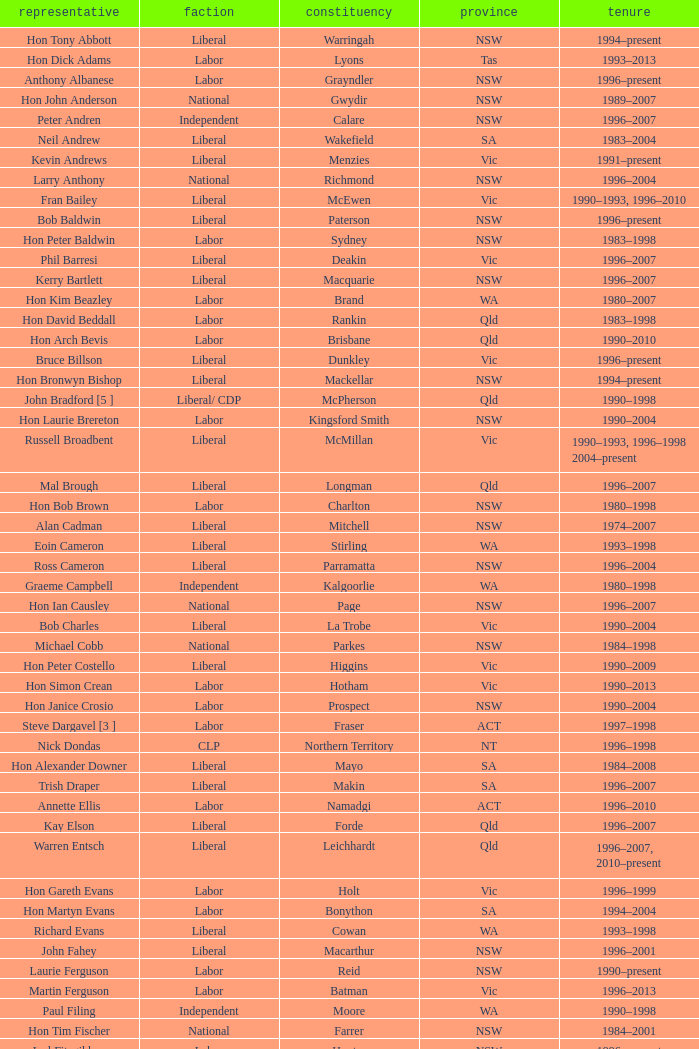Can you give me this table as a dict? {'header': ['representative', 'faction', 'constituency', 'province', 'tenure'], 'rows': [['Hon Tony Abbott', 'Liberal', 'Warringah', 'NSW', '1994–present'], ['Hon Dick Adams', 'Labor', 'Lyons', 'Tas', '1993–2013'], ['Anthony Albanese', 'Labor', 'Grayndler', 'NSW', '1996–present'], ['Hon John Anderson', 'National', 'Gwydir', 'NSW', '1989–2007'], ['Peter Andren', 'Independent', 'Calare', 'NSW', '1996–2007'], ['Neil Andrew', 'Liberal', 'Wakefield', 'SA', '1983–2004'], ['Kevin Andrews', 'Liberal', 'Menzies', 'Vic', '1991–present'], ['Larry Anthony', 'National', 'Richmond', 'NSW', '1996–2004'], ['Fran Bailey', 'Liberal', 'McEwen', 'Vic', '1990–1993, 1996–2010'], ['Bob Baldwin', 'Liberal', 'Paterson', 'NSW', '1996–present'], ['Hon Peter Baldwin', 'Labor', 'Sydney', 'NSW', '1983–1998'], ['Phil Barresi', 'Liberal', 'Deakin', 'Vic', '1996–2007'], ['Kerry Bartlett', 'Liberal', 'Macquarie', 'NSW', '1996–2007'], ['Hon Kim Beazley', 'Labor', 'Brand', 'WA', '1980–2007'], ['Hon David Beddall', 'Labor', 'Rankin', 'Qld', '1983–1998'], ['Hon Arch Bevis', 'Labor', 'Brisbane', 'Qld', '1990–2010'], ['Bruce Billson', 'Liberal', 'Dunkley', 'Vic', '1996–present'], ['Hon Bronwyn Bishop', 'Liberal', 'Mackellar', 'NSW', '1994–present'], ['John Bradford [5 ]', 'Liberal/ CDP', 'McPherson', 'Qld', '1990–1998'], ['Hon Laurie Brereton', 'Labor', 'Kingsford Smith', 'NSW', '1990–2004'], ['Russell Broadbent', 'Liberal', 'McMillan', 'Vic', '1990–1993, 1996–1998 2004–present'], ['Mal Brough', 'Liberal', 'Longman', 'Qld', '1996–2007'], ['Hon Bob Brown', 'Labor', 'Charlton', 'NSW', '1980–1998'], ['Alan Cadman', 'Liberal', 'Mitchell', 'NSW', '1974–2007'], ['Eoin Cameron', 'Liberal', 'Stirling', 'WA', '1993–1998'], ['Ross Cameron', 'Liberal', 'Parramatta', 'NSW', '1996–2004'], ['Graeme Campbell', 'Independent', 'Kalgoorlie', 'WA', '1980–1998'], ['Hon Ian Causley', 'National', 'Page', 'NSW', '1996–2007'], ['Bob Charles', 'Liberal', 'La Trobe', 'Vic', '1990–2004'], ['Michael Cobb', 'National', 'Parkes', 'NSW', '1984–1998'], ['Hon Peter Costello', 'Liberal', 'Higgins', 'Vic', '1990–2009'], ['Hon Simon Crean', 'Labor', 'Hotham', 'Vic', '1990–2013'], ['Hon Janice Crosio', 'Labor', 'Prospect', 'NSW', '1990–2004'], ['Steve Dargavel [3 ]', 'Labor', 'Fraser', 'ACT', '1997–1998'], ['Nick Dondas', 'CLP', 'Northern Territory', 'NT', '1996–1998'], ['Hon Alexander Downer', 'Liberal', 'Mayo', 'SA', '1984–2008'], ['Trish Draper', 'Liberal', 'Makin', 'SA', '1996–2007'], ['Annette Ellis', 'Labor', 'Namadgi', 'ACT', '1996–2010'], ['Kay Elson', 'Liberal', 'Forde', 'Qld', '1996–2007'], ['Warren Entsch', 'Liberal', 'Leichhardt', 'Qld', '1996–2007, 2010–present'], ['Hon Gareth Evans', 'Labor', 'Holt', 'Vic', '1996–1999'], ['Hon Martyn Evans', 'Labor', 'Bonython', 'SA', '1994–2004'], ['Richard Evans', 'Liberal', 'Cowan', 'WA', '1993–1998'], ['John Fahey', 'Liberal', 'Macarthur', 'NSW', '1996–2001'], ['Laurie Ferguson', 'Labor', 'Reid', 'NSW', '1990–present'], ['Martin Ferguson', 'Labor', 'Batman', 'Vic', '1996–2013'], ['Paul Filing', 'Independent', 'Moore', 'WA', '1990–1998'], ['Hon Tim Fischer', 'National', 'Farrer', 'NSW', '1984–2001'], ['Joel Fitzgibbon', 'Labor', 'Hunter', 'NSW', '1996–present'], ['John Forrest', 'National', 'Mallee', 'Vic', '1993–2013'], ['Christine Gallus', 'Liberal', 'Hindmarsh', 'SA', '1990–2004'], ['Teresa Gambaro', 'Liberal', 'Petrie', 'Qld', '1996–2007, 2010–present'], ['Joanna Gash', 'Liberal', 'Gilmore', 'NSW', '1996–2013'], ['Petro Georgiou', 'Liberal', 'Kooyong', 'Vic', '1994–2010'], ['Ted Grace', 'Labor', 'Fowler', 'NSW', '1984–1998'], ['Elizabeth Grace', 'Liberal', 'Lilley', 'Qld', '1996–1998'], ['Alan Griffin', 'Labor', 'Bruce', 'Vic', '1993–present'], ['Bob Halverson', 'Liberal', 'Casey', 'Vic', '1984–1998'], ['Pauline Hanson [4 ]', 'Independent/ ONP', 'Oxley', 'Qld', '1996–1998'], ['Gary Hardgrave', 'Liberal', 'Moreton', 'Qld', '1996–2007'], ['Michael Hatton [1 ]', 'Labor', 'Blaxland', 'NSW', '1996–2007'], ['David Hawker', 'Liberal', 'Wannon', 'Vic', '1983–2010'], ['Noel Hicks', 'National', 'Riverina', 'NSW', '1980–1998'], ['Joe Hockey', 'Liberal', 'North Sydney', 'NSW', '1996–present'], ['Hon Clyde Holding', 'Labor', 'Melbourne Ports', 'Vic', '1977–1998'], ['Colin Hollis', 'Labor', 'Throsby', 'NSW', '1984–2001'], ['Hon John Howard', 'Liberal', 'Bennelong', 'NSW', '1974–2007'], ['Susan Jeanes', 'Liberal', 'Kingston', 'SA', '1996–1998'], ['Harry Jenkins', 'Labor', 'Scullin', 'Vic', '1986–2013'], ['Ricky Johnston', 'Liberal', 'Canning', 'WA', '1996–1998'], ['Hon Barry Jones', 'Labor', 'Lalor', 'Vic', '1977–1998'], ['Hon David Jull', 'Liberal', 'Fadden', 'Qld', '1975–1983, 1984–2007'], ['Hon Bob Katter', 'National', 'Kennedy', 'Qld', '1993–present'], ['Paul Keating [1 ]', 'Labor', 'Blaxland', 'NSW', '1969–1996'], ['De-Anne Kelly', 'National', 'Dawson', 'Qld', '1996–2007'], ['Jackie Kelly [2 ]', 'Liberal', 'Lindsay', 'NSW', '1996–2007'], ['Hon Dr David Kemp', 'Liberal', 'Goldstein', 'Vic', '1990–2004'], ['Hon Duncan Kerr', 'Labor', 'Denison', 'Tas', '1987–2010'], ['John Langmore [3 ]', 'Labor', 'Fraser', 'ACT', '1984–1997'], ['Mark Latham', 'Labor', 'Werriwa', 'NSW', '1994–2005'], ['Hon Dr Carmen Lawrence', 'Labor', 'Fremantle', 'WA', '1994–2007'], ['Hon Michael Lee', 'Labor', 'Dobell', 'NSW', '1984–2001'], ['Hon Lou Lieberman', 'Liberal', 'Indi', 'Vic', '1993–2001'], ['Peter Lindsay', 'Liberal', 'Herbert', 'Qld', '1996–2010'], ['Jim Lloyd', 'Liberal', 'Robertson', 'NSW', '1996–2007'], ['Stewart McArthur', 'Liberal', 'Corangamite', 'Vic', '1984–2007'], ['Robert McClelland', 'Labor', 'Barton', 'NSW', '1996–2013'], ['Graeme McDougall', 'Liberal', 'Griffith', 'Qld', '1996–1998'], ['Hon Peter McGauran', 'National', 'Gippsland', 'Vic', '1983–2008'], ['Hon Ian McLachlan', 'Liberal', 'Barker', 'SA', '1990–1998'], ['Hon Leo McLeay', 'Labor', 'Watson', 'NSW', '1979–2004'], ['Hon Bob McMullan', 'Labor', 'Canberra', 'ACT', '1996–2010'], ['Jenny Macklin', 'Labor', 'Jagajaga', 'Vic', '1996–present'], ['Paul Marek', 'National', 'Capricornia', 'Qld', '1996–1998'], ['Hon Stephen Martin', 'Labor', 'Cunningham', 'NSW', '1984–2002'], ['Daryl Melham', 'Labor', 'Banks', 'NSW', '1990–2013'], ['Hon Chris Miles', 'Liberal', 'Braddon', 'Tas', '1984–1998'], ['Hon John Moore', 'Liberal', 'Ryan', 'Qld', '1975–2001'], ['Allan Morris', 'Labor', 'Newcastle', 'NSW', '1983–2001'], ['Hon Peter Morris', 'Labor', 'Shortland', 'NSW', '1972–1998'], ['Frank Mossfield', 'Labor', 'Greenway', 'NSW', '1996–2004'], ['Hon Judi Moylan', 'Liberal', 'Pearce', 'WA', '1993–2013'], ['Stephen Mutch', 'Liberal', 'Cook', 'NSW', '1996–1998'], ['Gary Nairn', 'Liberal', 'Eden-Monaro', 'NSW', '1996–2007'], ['Garry Nehl', 'National', 'Cowper', 'NSW', '1984–2001'], ['Dr Brendan Nelson', 'Liberal', 'Bradfield', 'NSW', '1996–2009'], ['Paul Neville', 'National', 'Hinkler', 'Qld', '1993–2013'], ['Peter Nugent', 'Liberal', 'Aston', 'Vic', '1990–2001'], ["Gavan O'Connor", 'Labor', 'Corio', 'Vic', '1993–2007'], ["Hon Neil O'Keefe", 'Labor', 'Burke', 'Vic', '1984–2001'], ['Hon Roger Price', 'Labor', 'Chifley', 'NSW', '1984–2010'], ['Hon Geoff Prosser', 'Liberal', 'Forrest', 'WA', '1987–2007'], ['Christopher Pyne', 'Liberal', 'Sturt', 'SA', '1993–present'], ['Harry Quick', 'Labor', 'Franklin', 'Tas', '1993–2007'], ['Don Randall', 'Liberal', 'Swan', 'WA', '1996–1998, 2001–present'], ['Hon Bruce Reid', 'Liberal', 'Bendigo', 'Vic', '1990–1998'], ['Hon Peter Reith', 'Liberal', 'Flinders', 'Vic', '1982–1983, 1984–2001'], ['Allan Rocher', 'Independent', 'Curtin', 'WA', '1981–1998'], ['Michael Ronaldson', 'Liberal', 'Ballarat', 'Vic', '1990–2001'], ['Hon Philip Ruddock', 'Liberal', 'Berowra', 'NSW', '1973–present'], ['Rod Sawford', 'Labor', 'Adelaide', 'SA', '1988–2007'], ['Hon Bruce Scott', 'National', 'Maranoa', 'Qld', '1990–present'], ['Bob Sercombe', 'Labor', 'Maribyrnong', 'Vic', '1996–2007'], ['Hon John Sharp', 'National', 'Hume', 'NSW', '1984–1998'], ['Hon Ian Sinclair', 'National', 'New England', 'NSW', '1963–1998'], ['Peter Slipper', 'Liberal', 'Fisher', 'Qld', '1984–1987, 1993–2013'], ['Tony Smith', 'Liberal/Independent [7 ]', 'Dickson', 'Qld', '1996–1998'], ['Stephen Smith', 'Labor', 'Perth', 'WA', '1993–2013'], ['Hon Warwick Smith', 'Liberal', 'Bass', 'Tas', '1984–1993, 1996–1998'], ['Alex Somlyay', 'Liberal', 'Fairfax', 'Qld', '1990–2013'], ['Dr Andrew Southcott', 'Liberal', 'Boothby', 'SA', '1996–present'], ['Dr Sharman Stone', 'Liberal', 'Murray', 'Vic', '1996–present'], ['Kathy Sullivan', 'Liberal', 'Moncrieff', 'Qld', '1984–2001'], ['Lindsay Tanner', 'Labor', 'Melbourne', 'Vic', '1993–2010'], ['Bill Taylor', 'Liberal', 'Groom', 'Qld', '1988–1998'], ['Hon Andrew Theophanous', 'Labor', 'Calwell', 'Vic', '1980–2001'], ['Hon Andrew Thomson', 'Liberal', 'Wentworth', 'NSW', '1995–2001'], ['Kelvin Thomson', 'Labor', 'Wills', 'Vic', '1996–present'], ['Warren Truss', 'National', 'Wide Bay', 'Qld', '1990–present'], ['Wilson Tuckey', 'Liberal', "O'Connor", 'WA', '1980–2010'], ['Mark Vaile', 'National', 'Lyne', 'NSW', '1993–2008'], ['Danna Vale', 'Liberal', 'Hughes', 'NSW', '1996–2010'], ['Barry Wakelin', 'Liberal', 'Grey', 'SA', '1993–2007'], ['Andrea West', 'Liberal', 'Bowman', 'Qld', '1996–1998'], ['Hon Daryl Williams', 'Liberal', 'Tangney', 'WA', '1993–2004'], ['Hon Ralph Willis', 'Labor', 'Gellibrand', 'Vic', '1972–1998'], ['Greg Wilton', 'Labor', 'Isaacs', 'Vic', '1996–2000'], ['Hon Michael Wooldridge', 'Liberal', 'Casey', 'Vic', '1987–2001'], ['Trish Worth', 'Liberal', 'Adelaide', 'SA', '1996–2004'], ['Paul Zammit', 'Liberal/Independent [6 ]', 'Lowe', 'NSW', '1996–1998']]} In what state was the electorate fowler? NSW. 